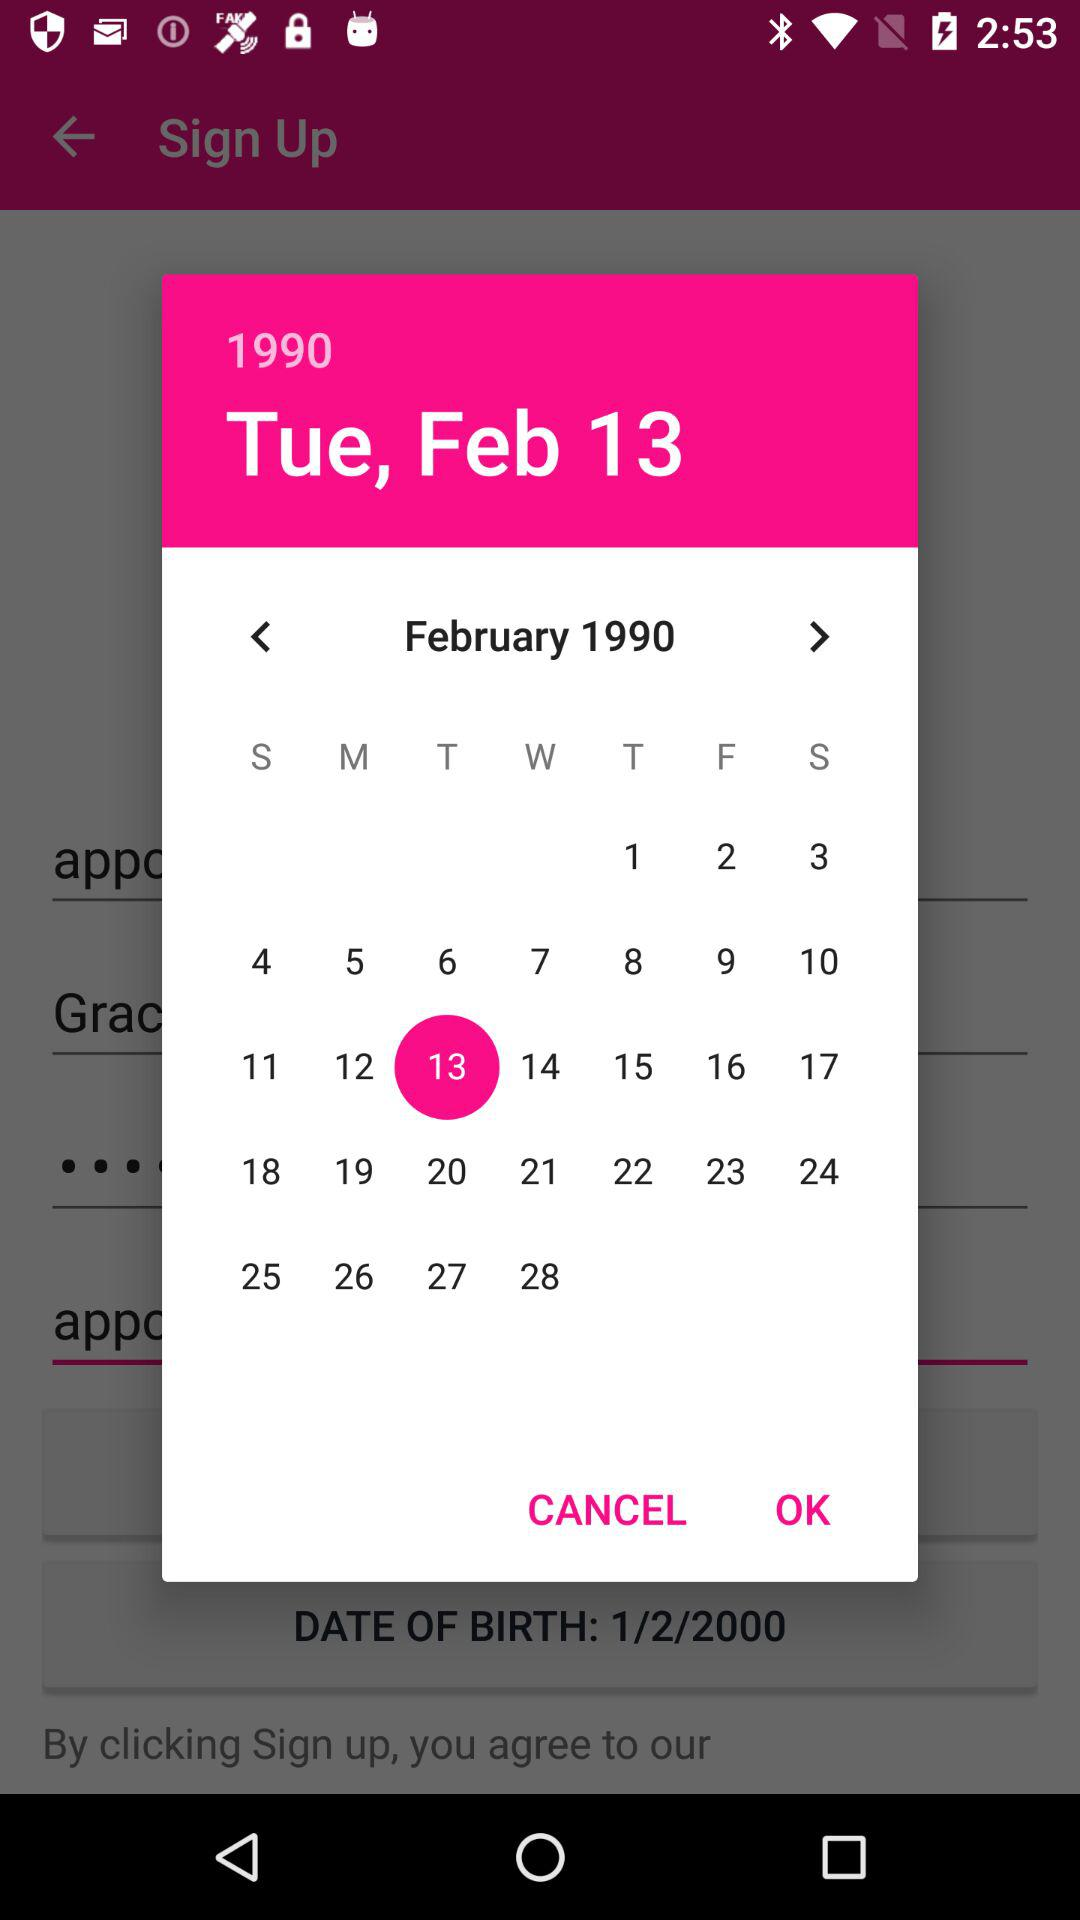What is the day on the 28th of February? The day is Tuesday. 